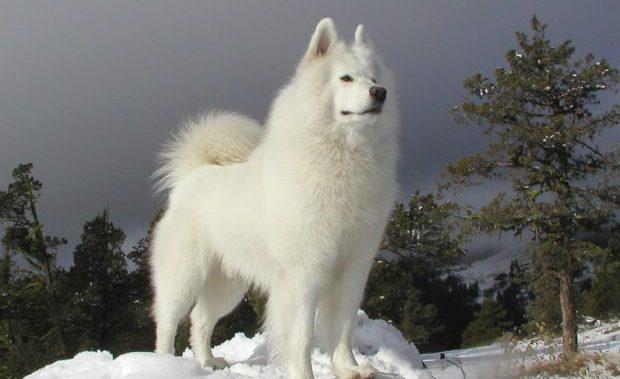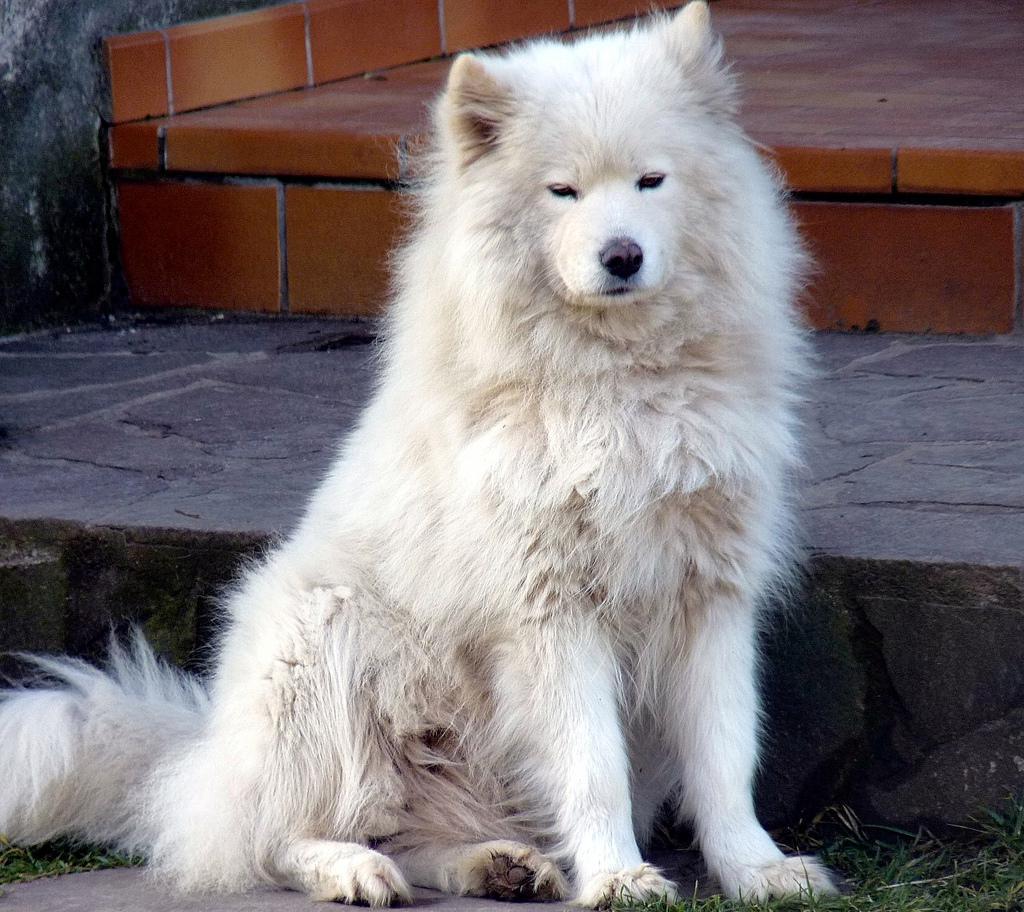The first image is the image on the left, the second image is the image on the right. Assess this claim about the two images: "there is at least one dog stading in the snow in the image pair". Correct or not? Answer yes or no. Yes. The first image is the image on the left, the second image is the image on the right. Considering the images on both sides, is "At least one dog is in the snow." valid? Answer yes or no. Yes. 